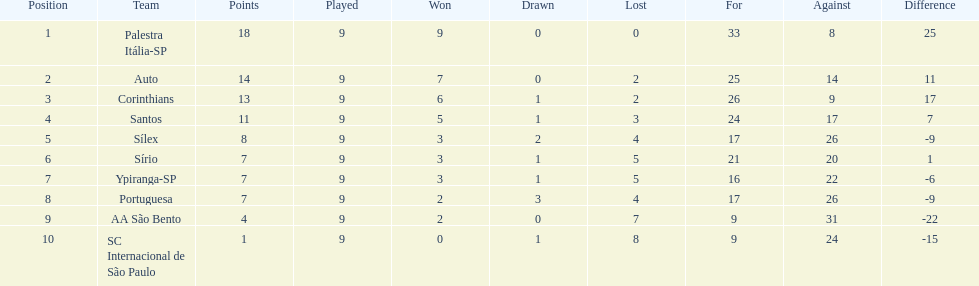In the 1926 brazilian football season, how many teams managed to score over 10 points? 4. 